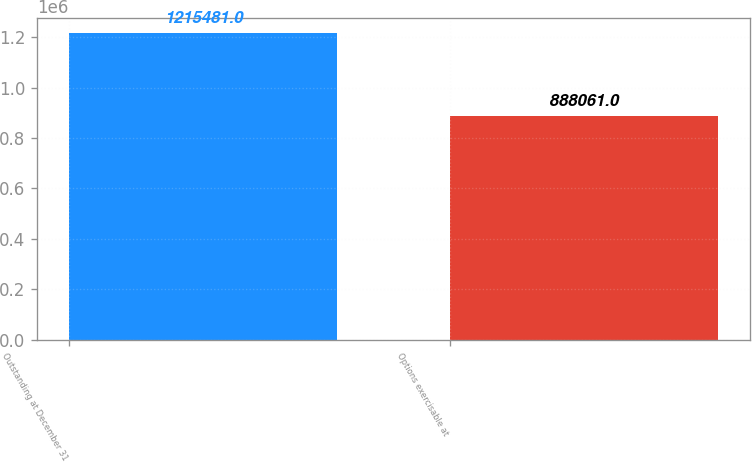Convert chart to OTSL. <chart><loc_0><loc_0><loc_500><loc_500><bar_chart><fcel>Outstanding at December 31<fcel>Options exercisable at<nl><fcel>1.21548e+06<fcel>888061<nl></chart> 